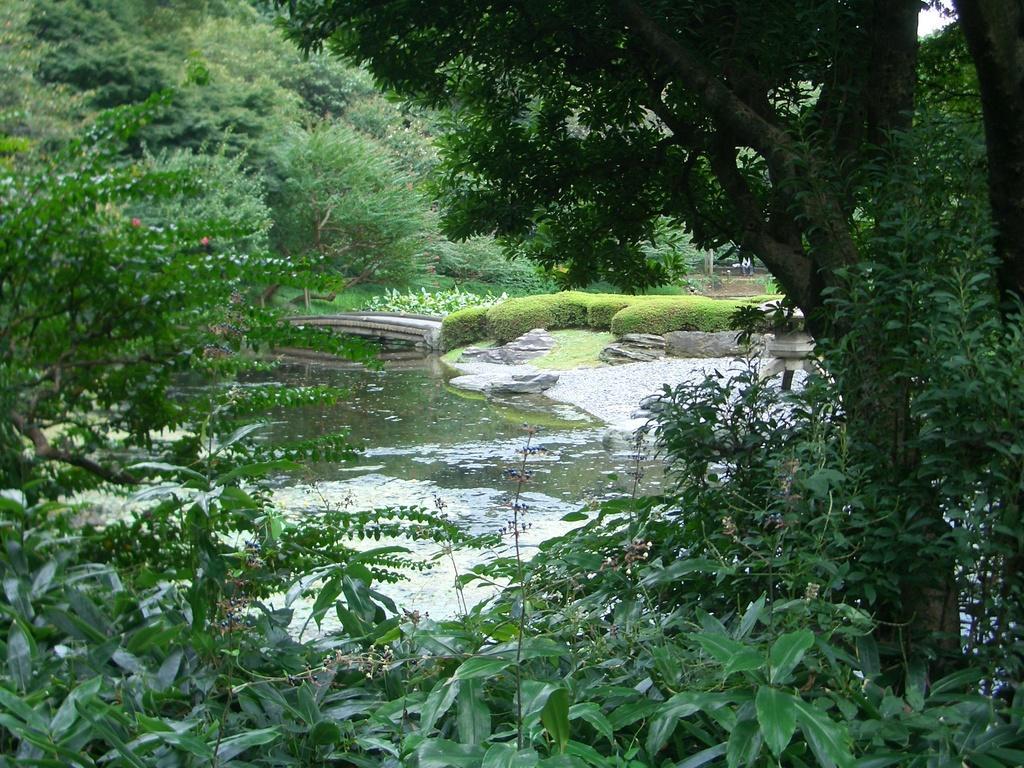In one or two sentences, can you explain what this image depicts? In this image I can see the water. To the side of the water I can see the ground, railing and the plants. And there are many trees around the water. In the back I can see the sky. 